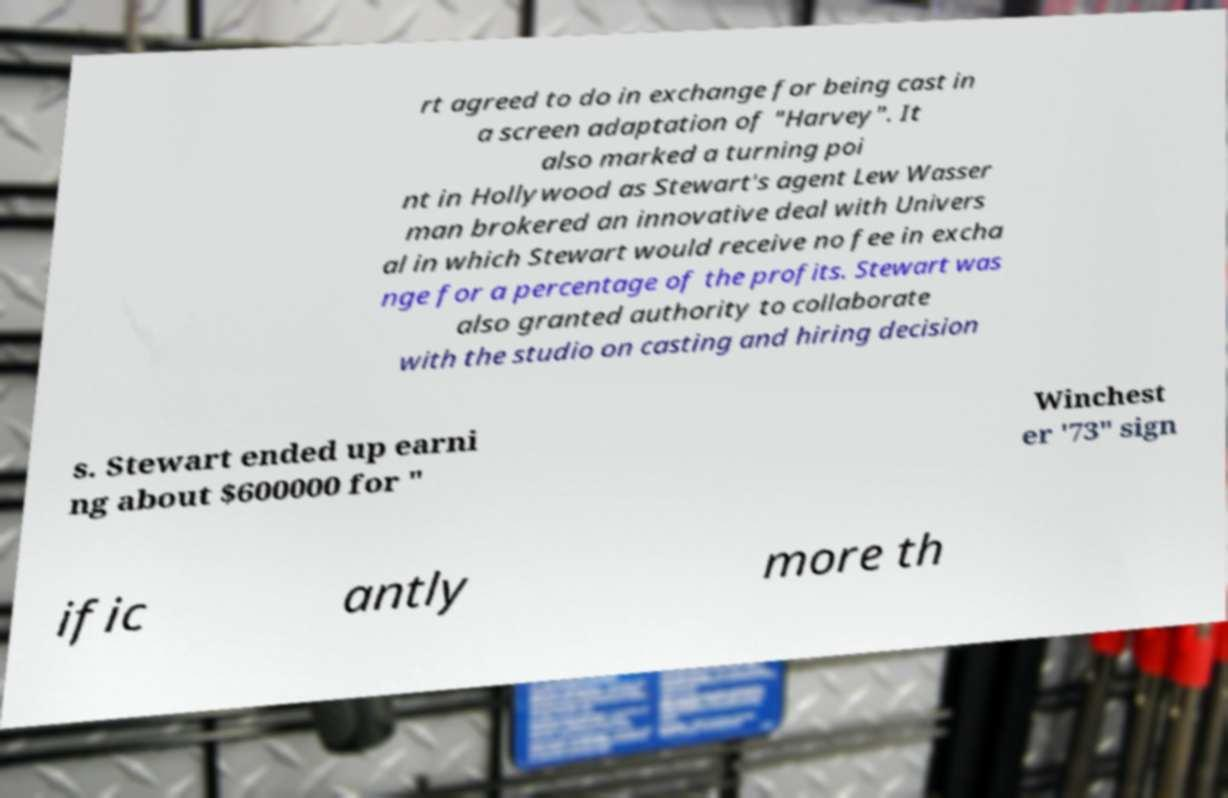There's text embedded in this image that I need extracted. Can you transcribe it verbatim? rt agreed to do in exchange for being cast in a screen adaptation of "Harvey". It also marked a turning poi nt in Hollywood as Stewart's agent Lew Wasser man brokered an innovative deal with Univers al in which Stewart would receive no fee in excha nge for a percentage of the profits. Stewart was also granted authority to collaborate with the studio on casting and hiring decision s. Stewart ended up earni ng about $600000 for " Winchest er '73" sign ific antly more th 